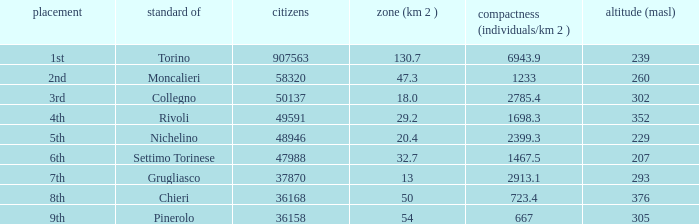The common of Chieri has what population density? 723.4. 